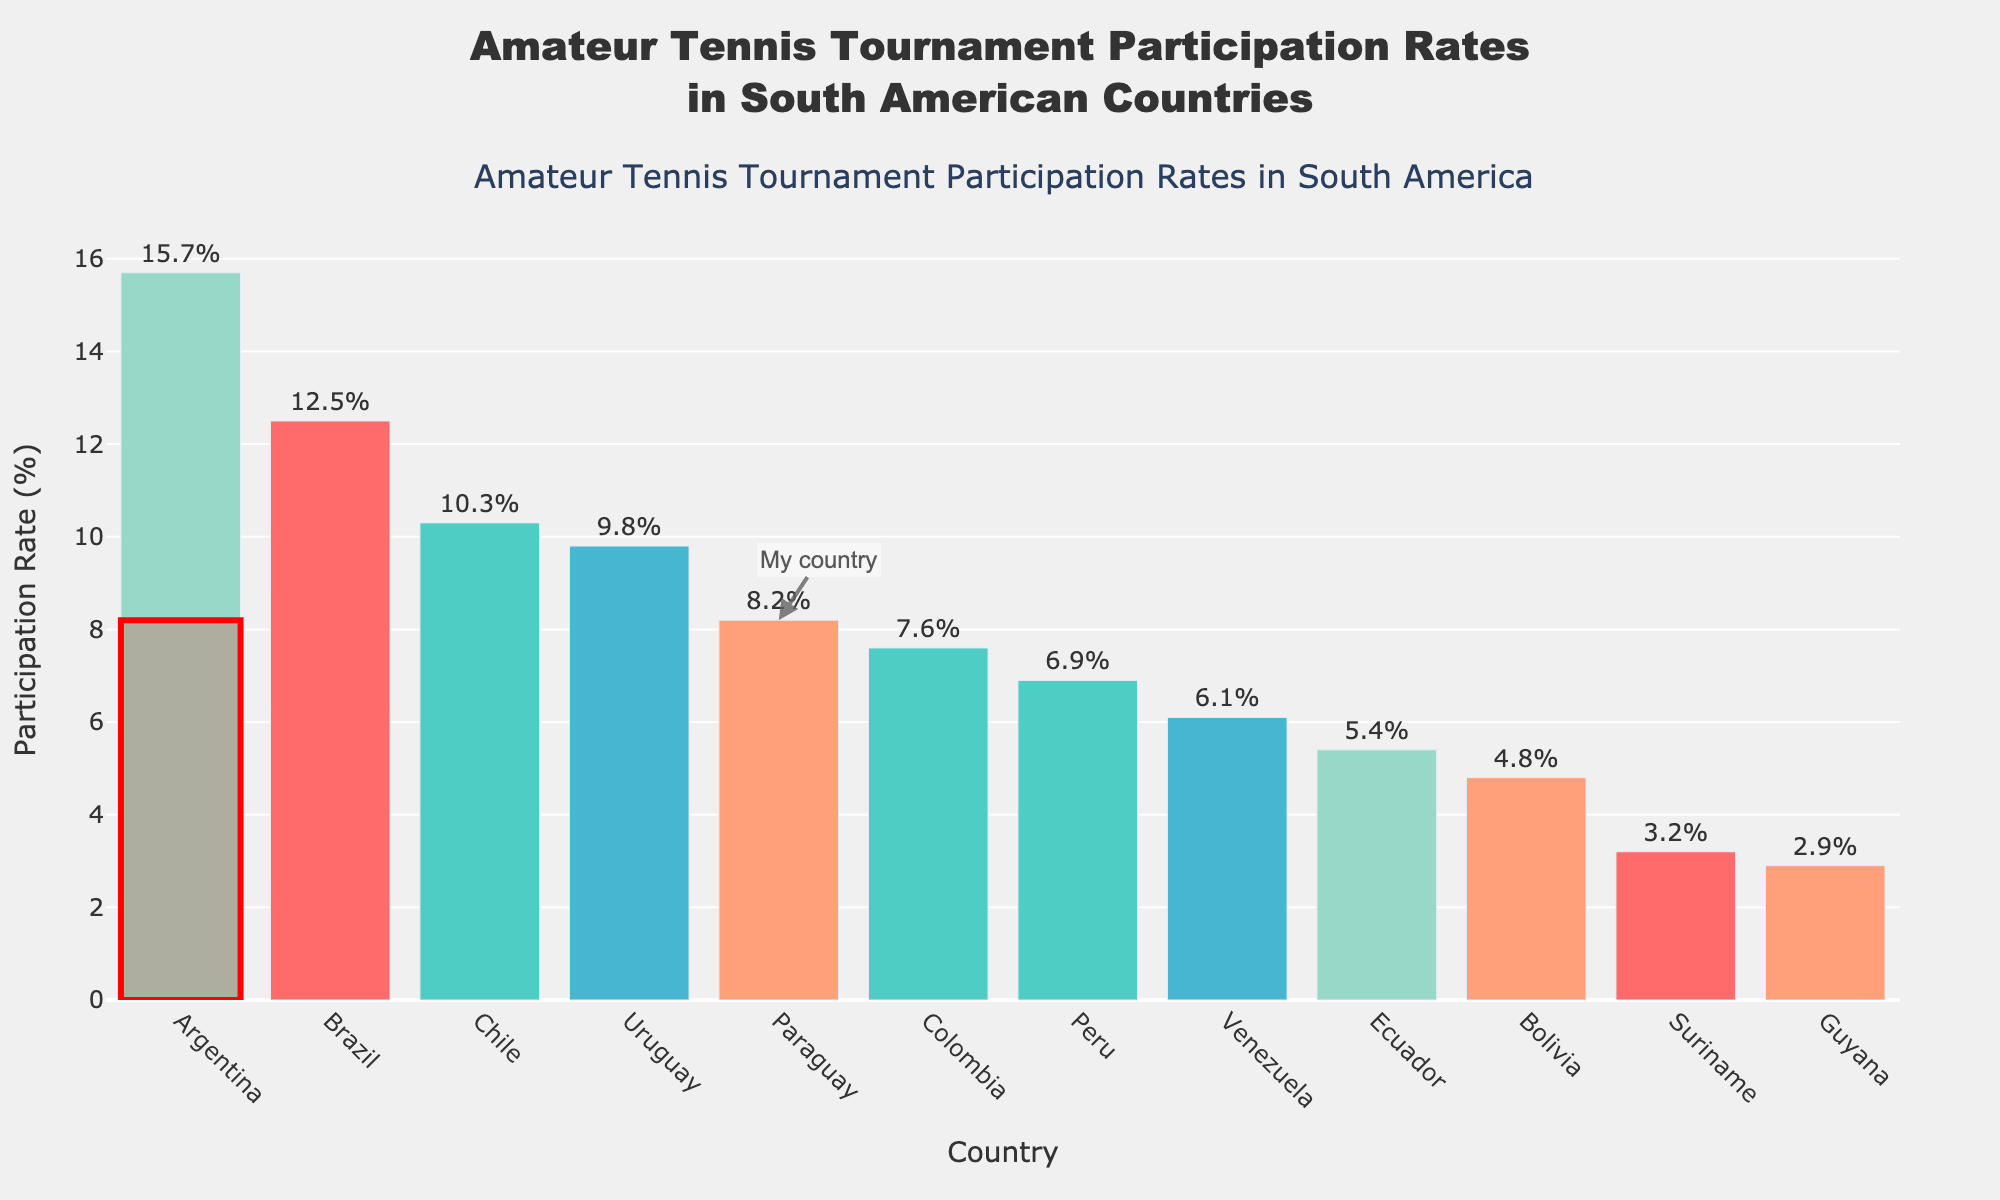What is the country with the highest participation rate in amateur tennis tournaments? The country with the highest participation rate can be identified by looking at the tallest bar in the bar chart.
Answer: Argentina What is the combined participation rate of Uruguay and Chile? From the figure, the participation rate for Uruguay is 9.8% and for Chile is 10.3%. Adding these together: 9.8% + 10.3% = 20.1%.
Answer: 20.1% How does Paraguay's participation rate compare to Colombia's? From the figure, Paraguay has a participation rate of 8.2% and Colombia has 7.6%. Since 8.2% is greater than 7.6%, Paraguay's participation rate is higher than Colombia's.
Answer: Paraguay's rate is higher than Colombia's Which country has the lowest participation rate? The country with the lowest participation rate can be identified by looking at the shortest bar in the bar chart.
Answer: Guyana What is the range of participation rates among the countries? The range is calculated by subtracting the smallest participation rate from the highest participation rate. The highest is Argentina with 15.7% and the lowest is Guyana with 2.9%. 15.7% - 2.9% = 12.8%.
Answer: 12.8% Which countries have a participation rate higher than 10%? From the figure, the countries with participation rates higher than 10% are Brazil (12.5%), Argentina (15.7%), and Chile (10.3%).
Answer: Brazil, Argentina, Chile What is the average participation rate across all the countries? To calculate the average, sum all participation rates and divide by the number of countries. Sum = 8.2 + 12.5 + 15.7 + 10.3 + 9.8 + 7.6 + 6.9 + 5.4 + 4.8 + 6.1 + 3.2 + 2.9 = 93.4%, Number of countries = 12. Average = 93.4 / 12 ≈ 7.78%.
Answer: 7.78% Does Paraguay have a higher participation rate than the median value of the data? First, identify the median participation rate by sorting the data. The median is the middle value. With 12 countries, the median is the average of the 6th and 7th values. Sorted: 2.9, 3.2, 4.8, 5.4, 6.1, 6.9, 7.6, 8.2, 9.8, 10.3, 12.5, 15.7. Median = (6.9 + 7.6) / 2 = 7.25%. Paraguay has a rate of 8.2%, which is higher than 7.25%.
Answer: Yes, Paraguay's rate is higher What visual element is used to highlight Paraguay on the bar chart? Paraguay is highlighted with a red rectangle around the bar and an annotation "My country."
Answer: Red rectangle and annotation 